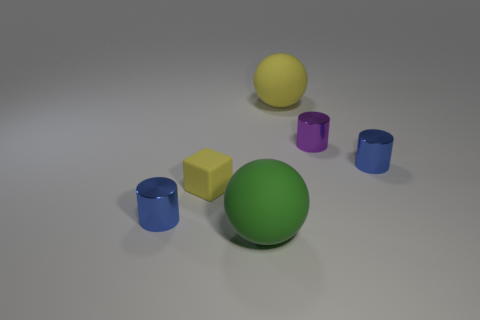Is the number of gray metallic things less than the number of big green things? Indeed, the quantity of gray metallic things, which are a total of three cylinders, is less than the number of large green objects, which includes one large sphere. It's an interesting observation highlighting the composition of shapes and colors in the image. 